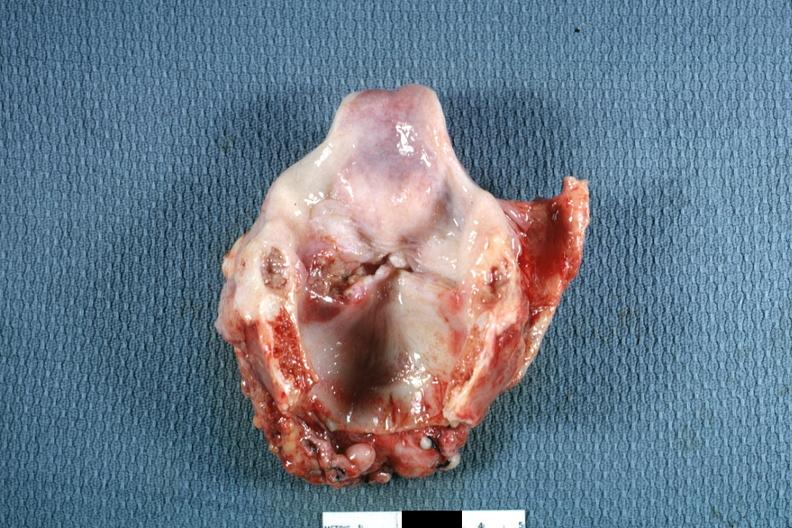what is ulcerative lesion left?
Answer the question using a single word or phrase. True cord quite good 